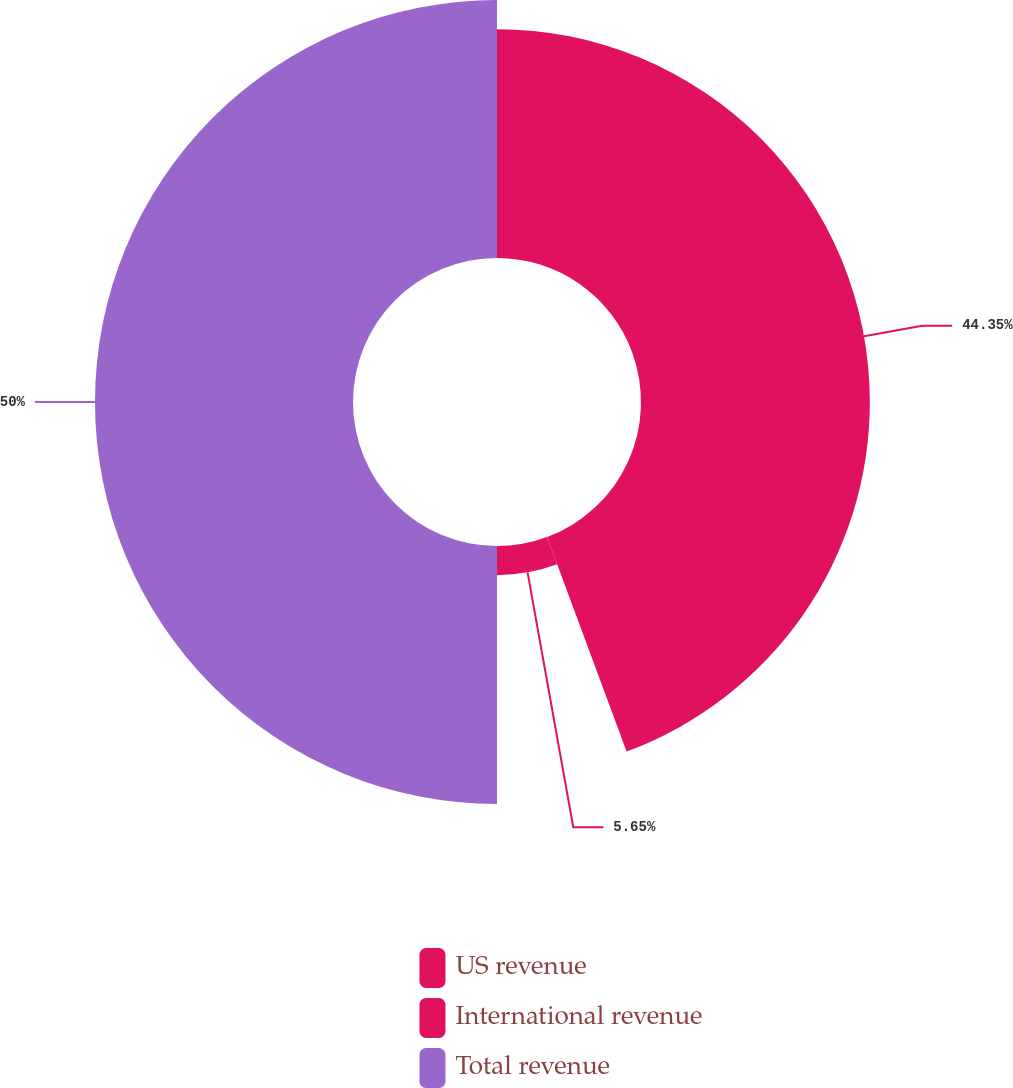<chart> <loc_0><loc_0><loc_500><loc_500><pie_chart><fcel>US revenue<fcel>International revenue<fcel>Total revenue<nl><fcel>44.35%<fcel>5.65%<fcel>50.0%<nl></chart> 